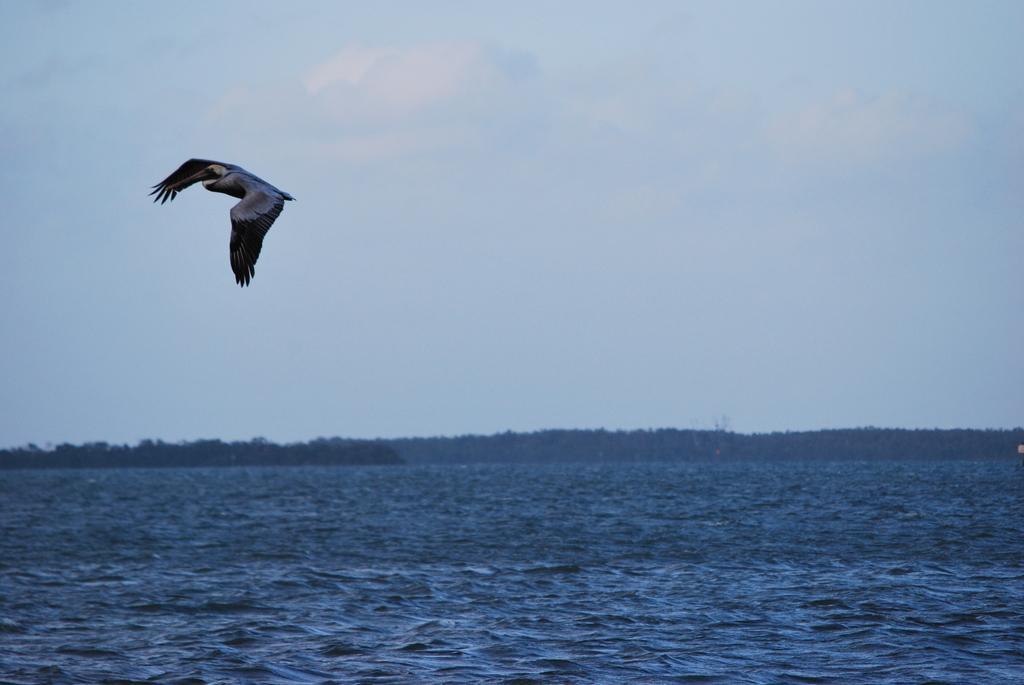What is the bird doing in the image? The bird is flying in the air in the image. What colors can be seen on the bird? The bird is black and grey in color. What can be seen below the bird in the image? There is water visible in the image. What color is the water? The water is blue in color. What is visible in the background of the image? There are mountains and the sky in the background of the image. Can you see any snails joining the bird in the image? There are no snails present in the image, and therefore no snails are joining the bird. How does the earthquake affect the bird in the image? There is no earthquake present in the image, so it does not affect the bird. 